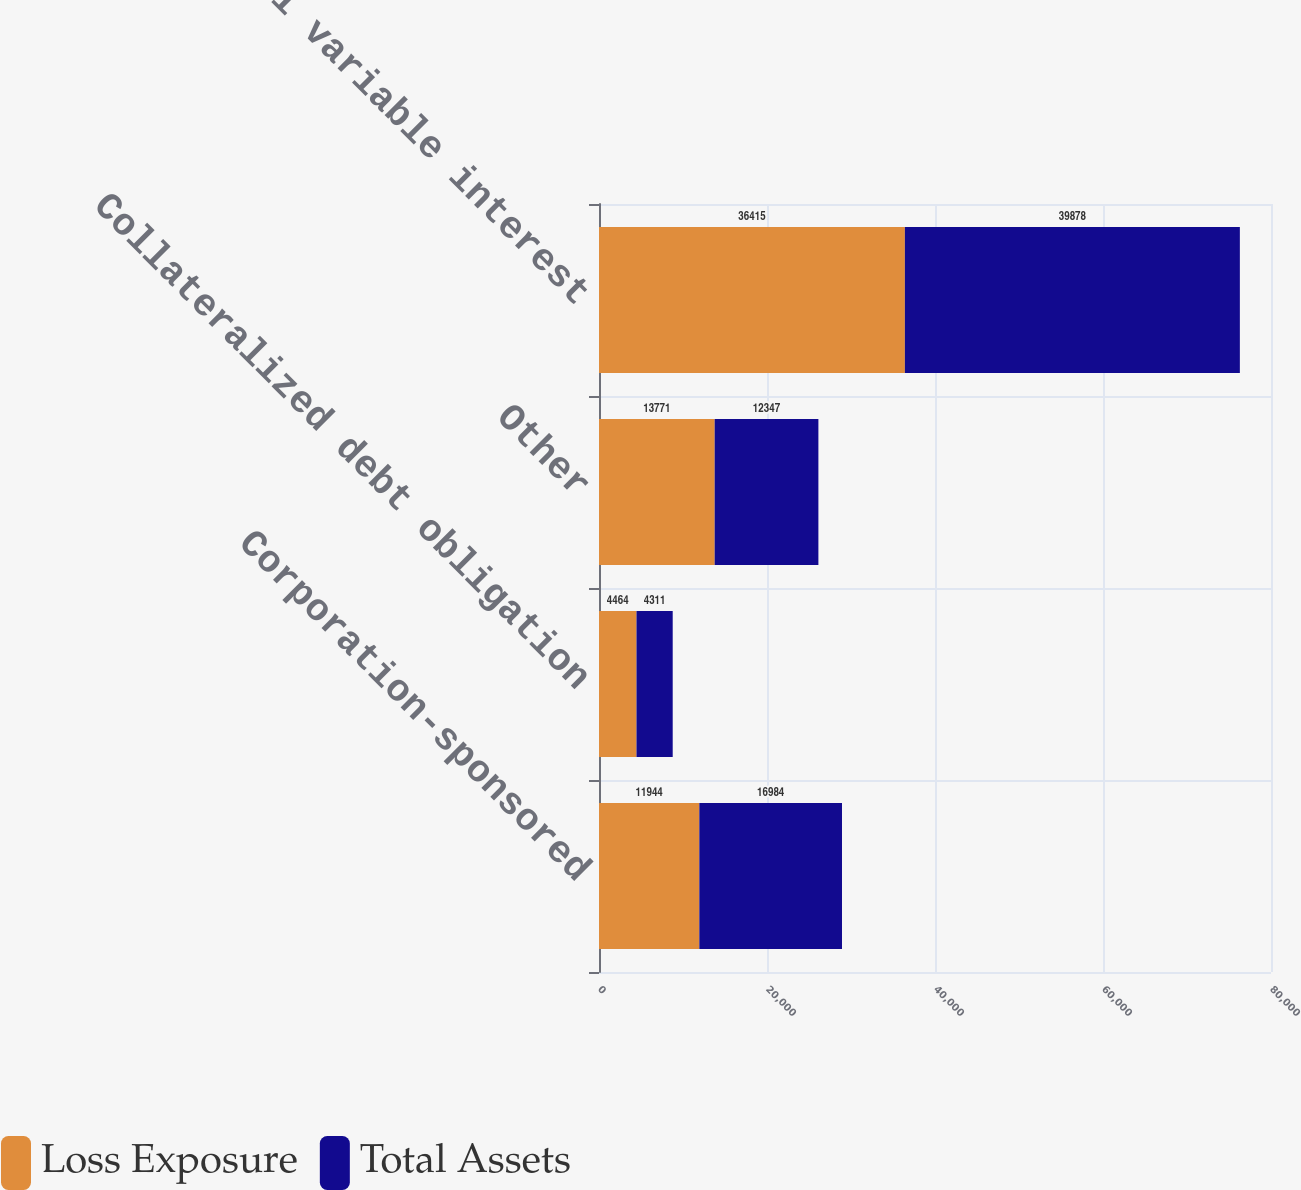Convert chart to OTSL. <chart><loc_0><loc_0><loc_500><loc_500><stacked_bar_chart><ecel><fcel>Corporation-sponsored<fcel>Collateralized debt obligation<fcel>Other<fcel>Total variable interest<nl><fcel>Loss Exposure<fcel>11944<fcel>4464<fcel>13771<fcel>36415<nl><fcel>Total Assets<fcel>16984<fcel>4311<fcel>12347<fcel>39878<nl></chart> 